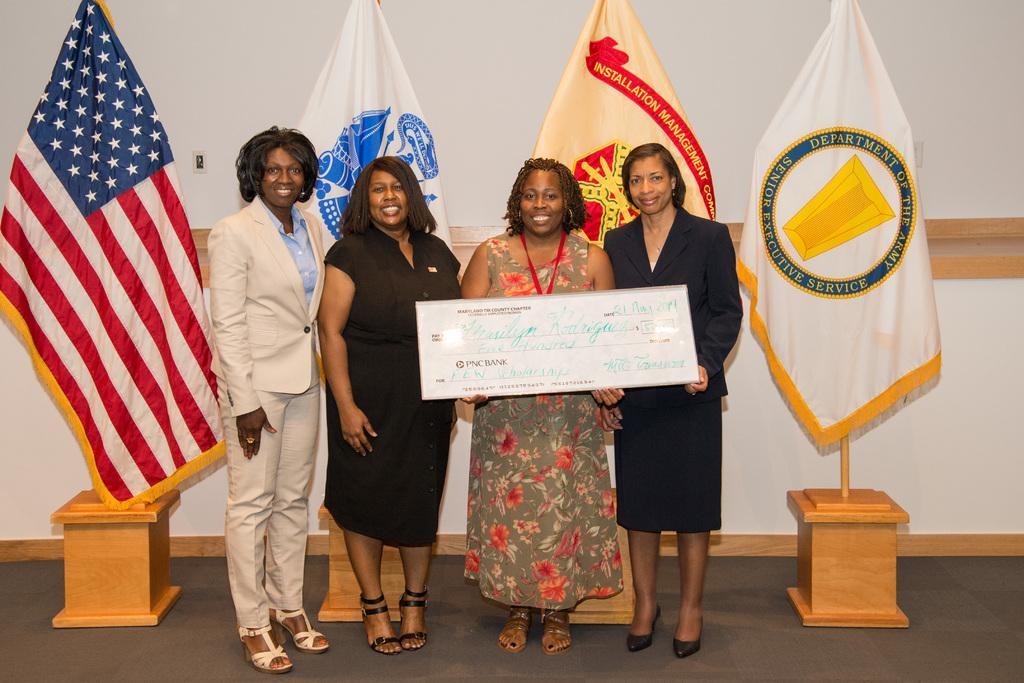Could you give a brief overview of what you see in this image? In the middle a woman is standing by holding a cheque in her hands. Beside her 2 women are standing, they wore black color coats. On the left side a woman is smiling, behind them there are flags of different countries. 